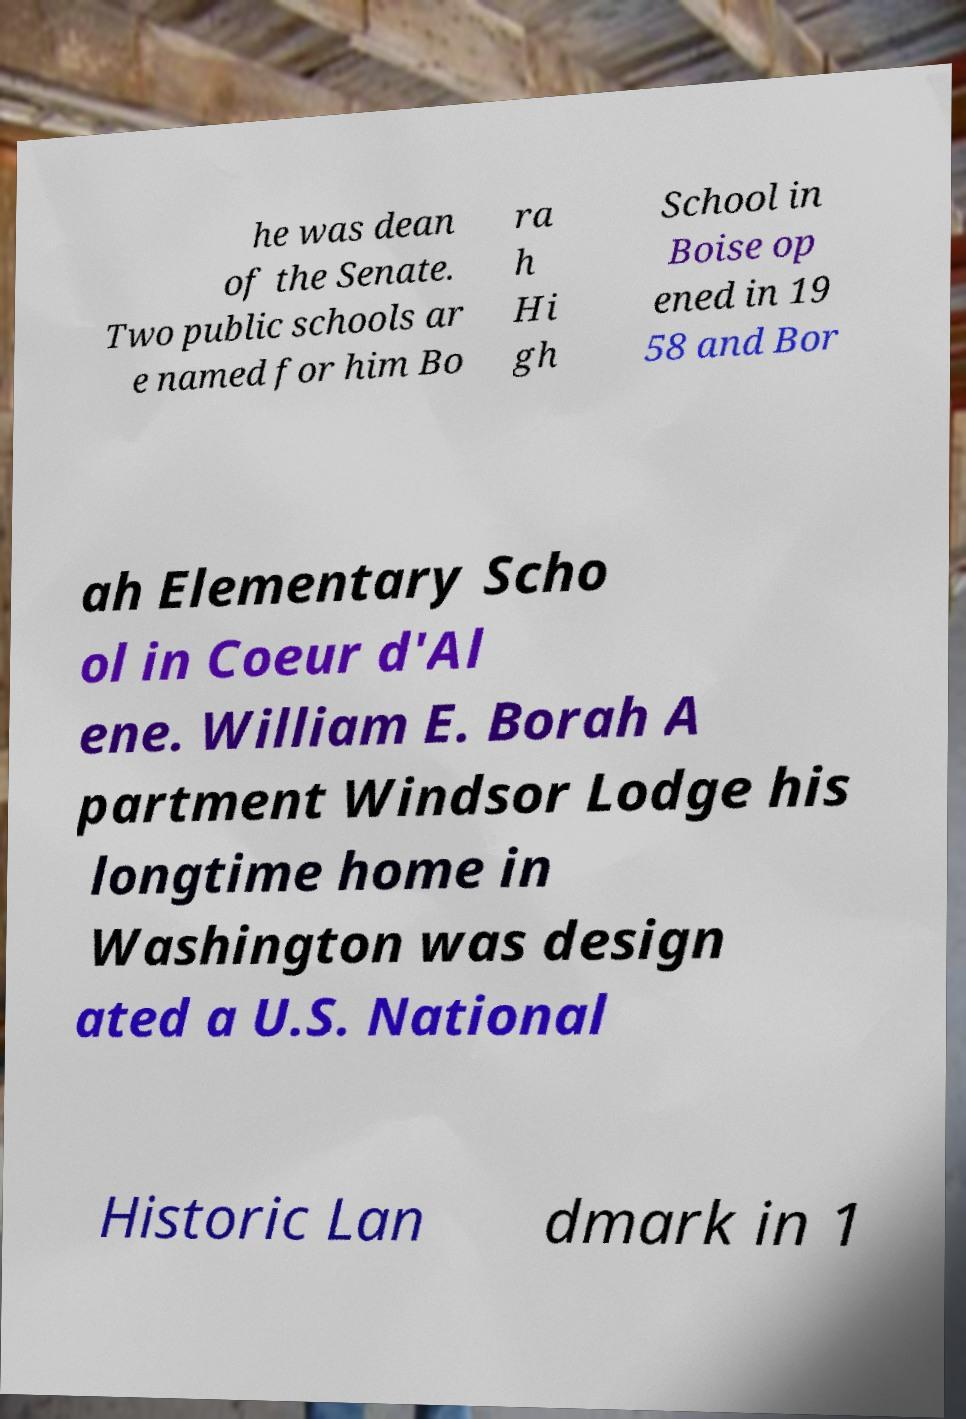For documentation purposes, I need the text within this image transcribed. Could you provide that? he was dean of the Senate. Two public schools ar e named for him Bo ra h Hi gh School in Boise op ened in 19 58 and Bor ah Elementary Scho ol in Coeur d'Al ene. William E. Borah A partment Windsor Lodge his longtime home in Washington was design ated a U.S. National Historic Lan dmark in 1 